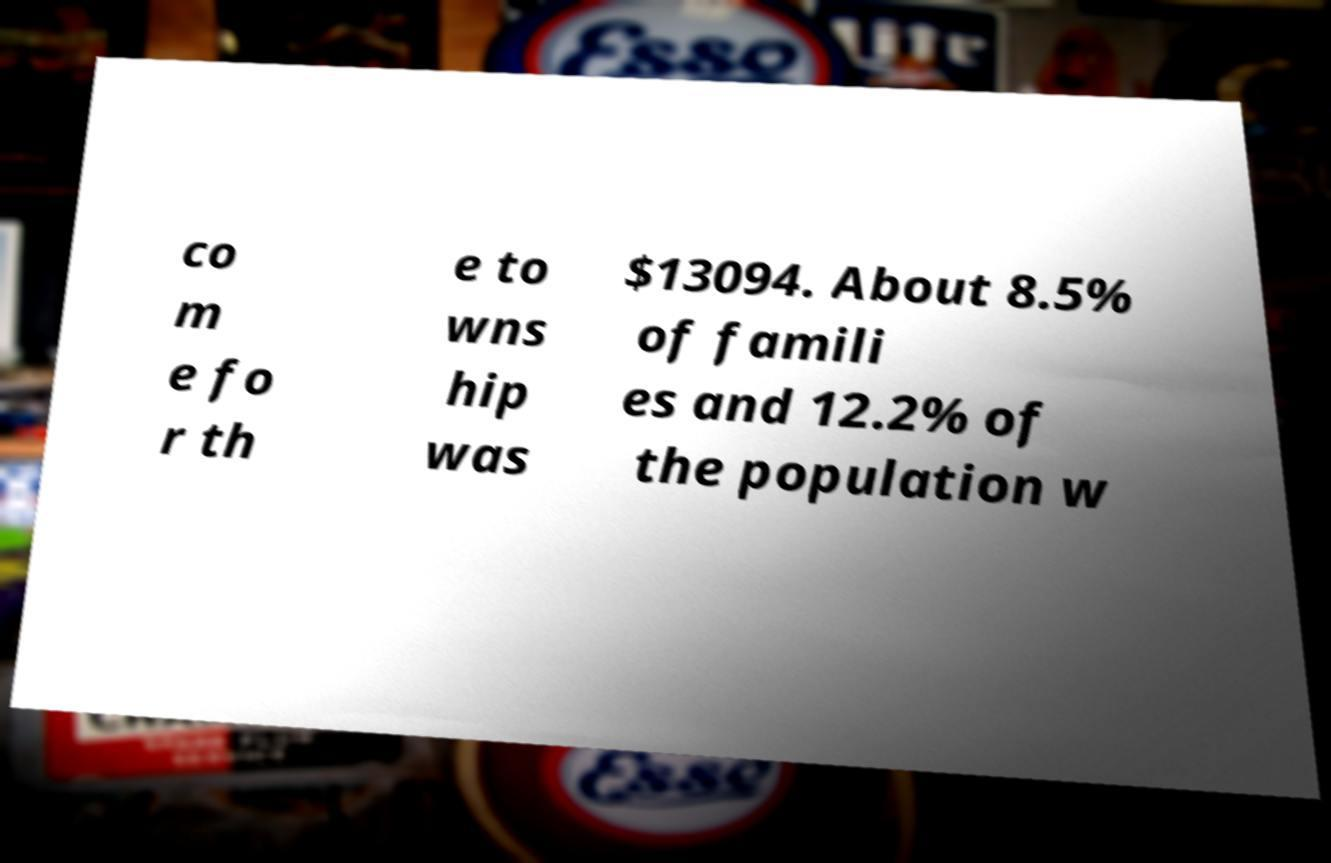Can you read and provide the text displayed in the image?This photo seems to have some interesting text. Can you extract and type it out for me? co m e fo r th e to wns hip was $13094. About 8.5% of famili es and 12.2% of the population w 